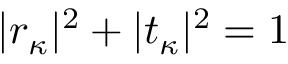<formula> <loc_0><loc_0><loc_500><loc_500>| r _ { \kappa } | ^ { 2 } + | t _ { \kappa } | ^ { 2 } = 1</formula> 